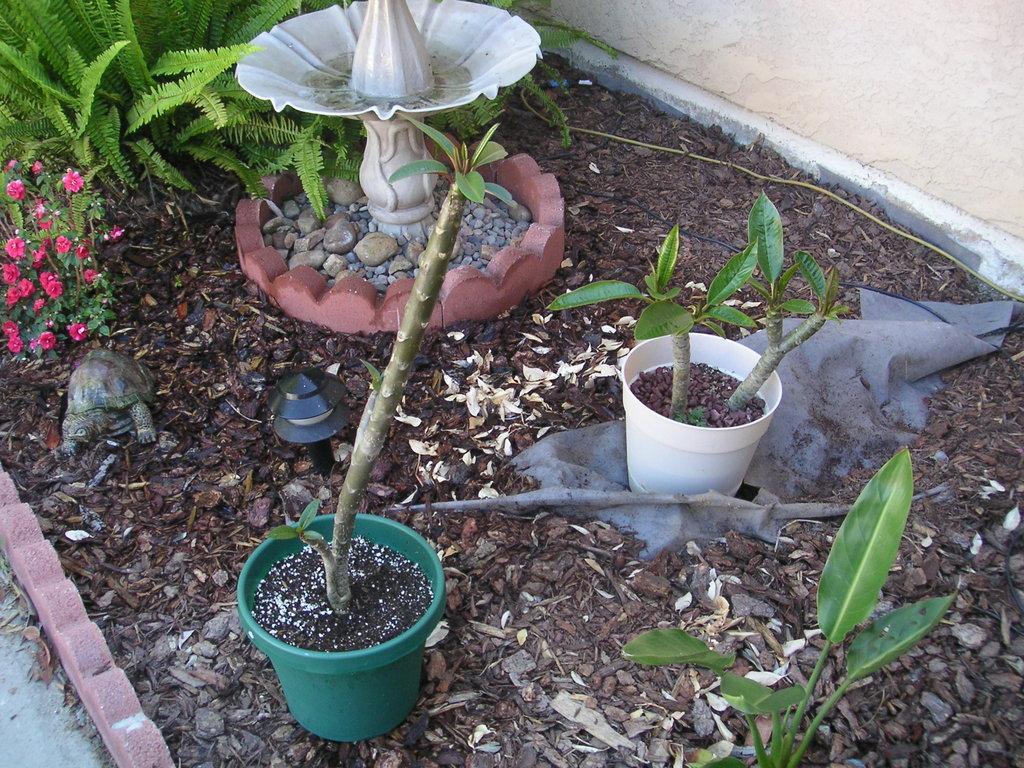Please provide a concise description of this image. In the center of the image there is a fountain. At the top left corner there is a plants and flowers. At the bottom we can see plants. At the top right corner there is a wall. 